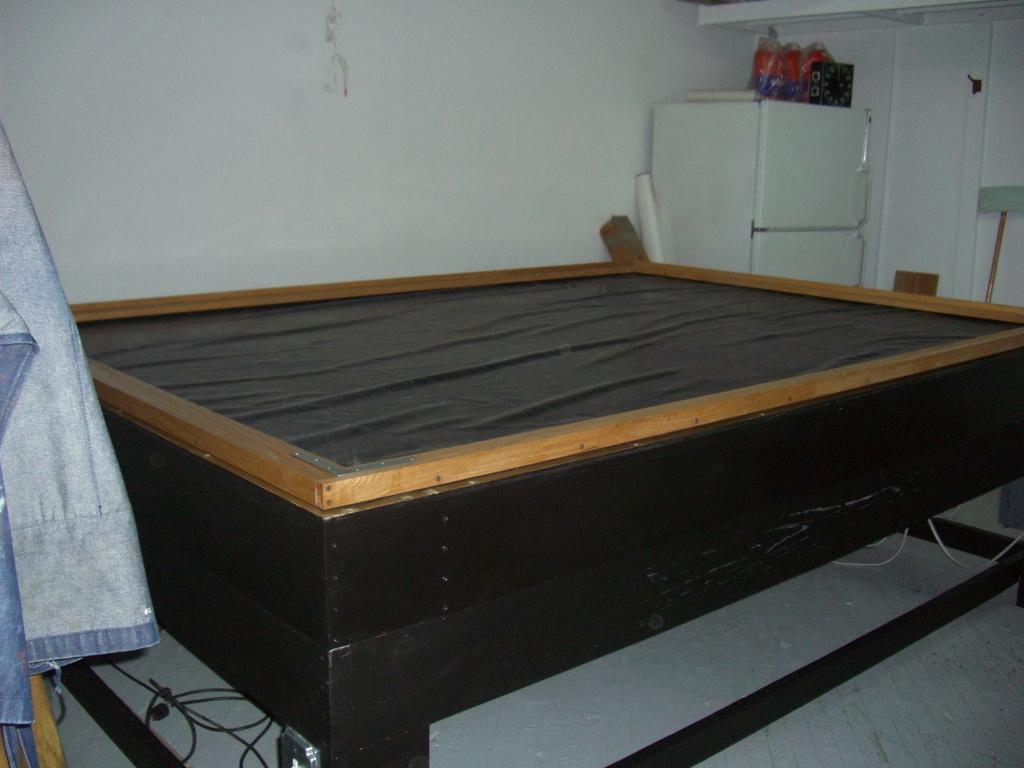Describe this image in one or two sentences. In the background we can see the wall. We can see objects on the top of a refrigerator. We can see few objects near to a refrigerator. In this picture we can see a bed frame. On the left side of the picture we can see a cloth. At the bottom portion of the picture we can see the wires on the floor. 